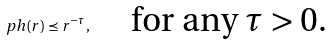Convert formula to latex. <formula><loc_0><loc_0><loc_500><loc_500>\ p h ( r ) \preceq r ^ { - \tau } , \quad \text { for any $\tau>0$.}</formula> 